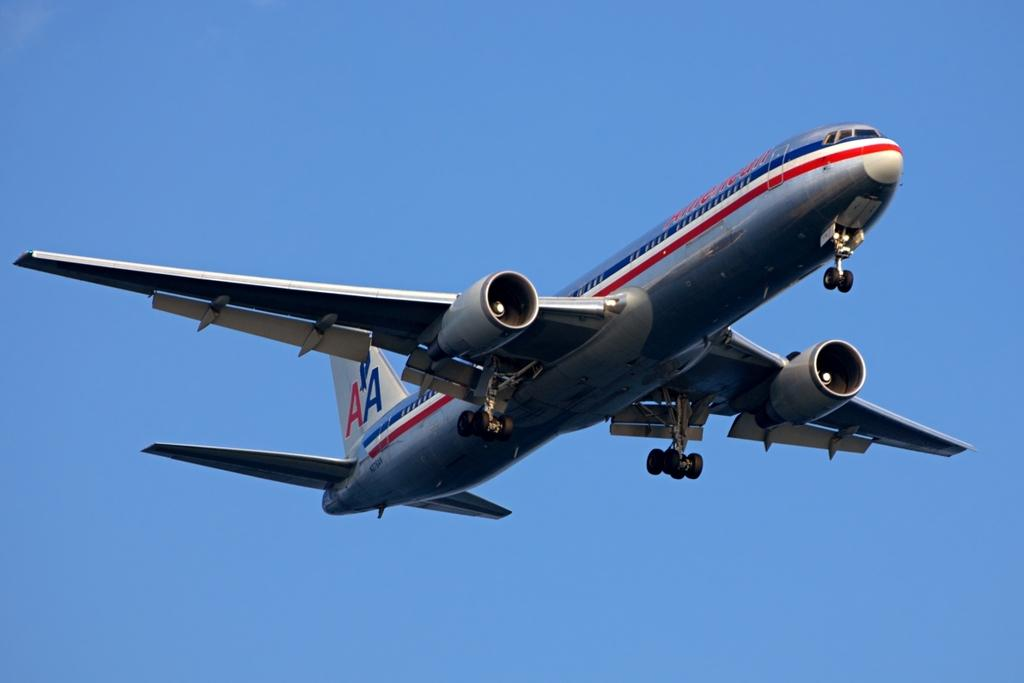What is the main subject of the image? The main subject of the image is an aeroplane. Where is the aeroplane located in the image? The aeroplane is in the sky. How many boys are using the aeroplane in the image? There are no boys present in the image, and the aeroplane is not being used by anyone. What are the friends doing while the aeroplane is in the sky? There are no friends present in the image, as the focus is solely on the aeroplane in the sky. 